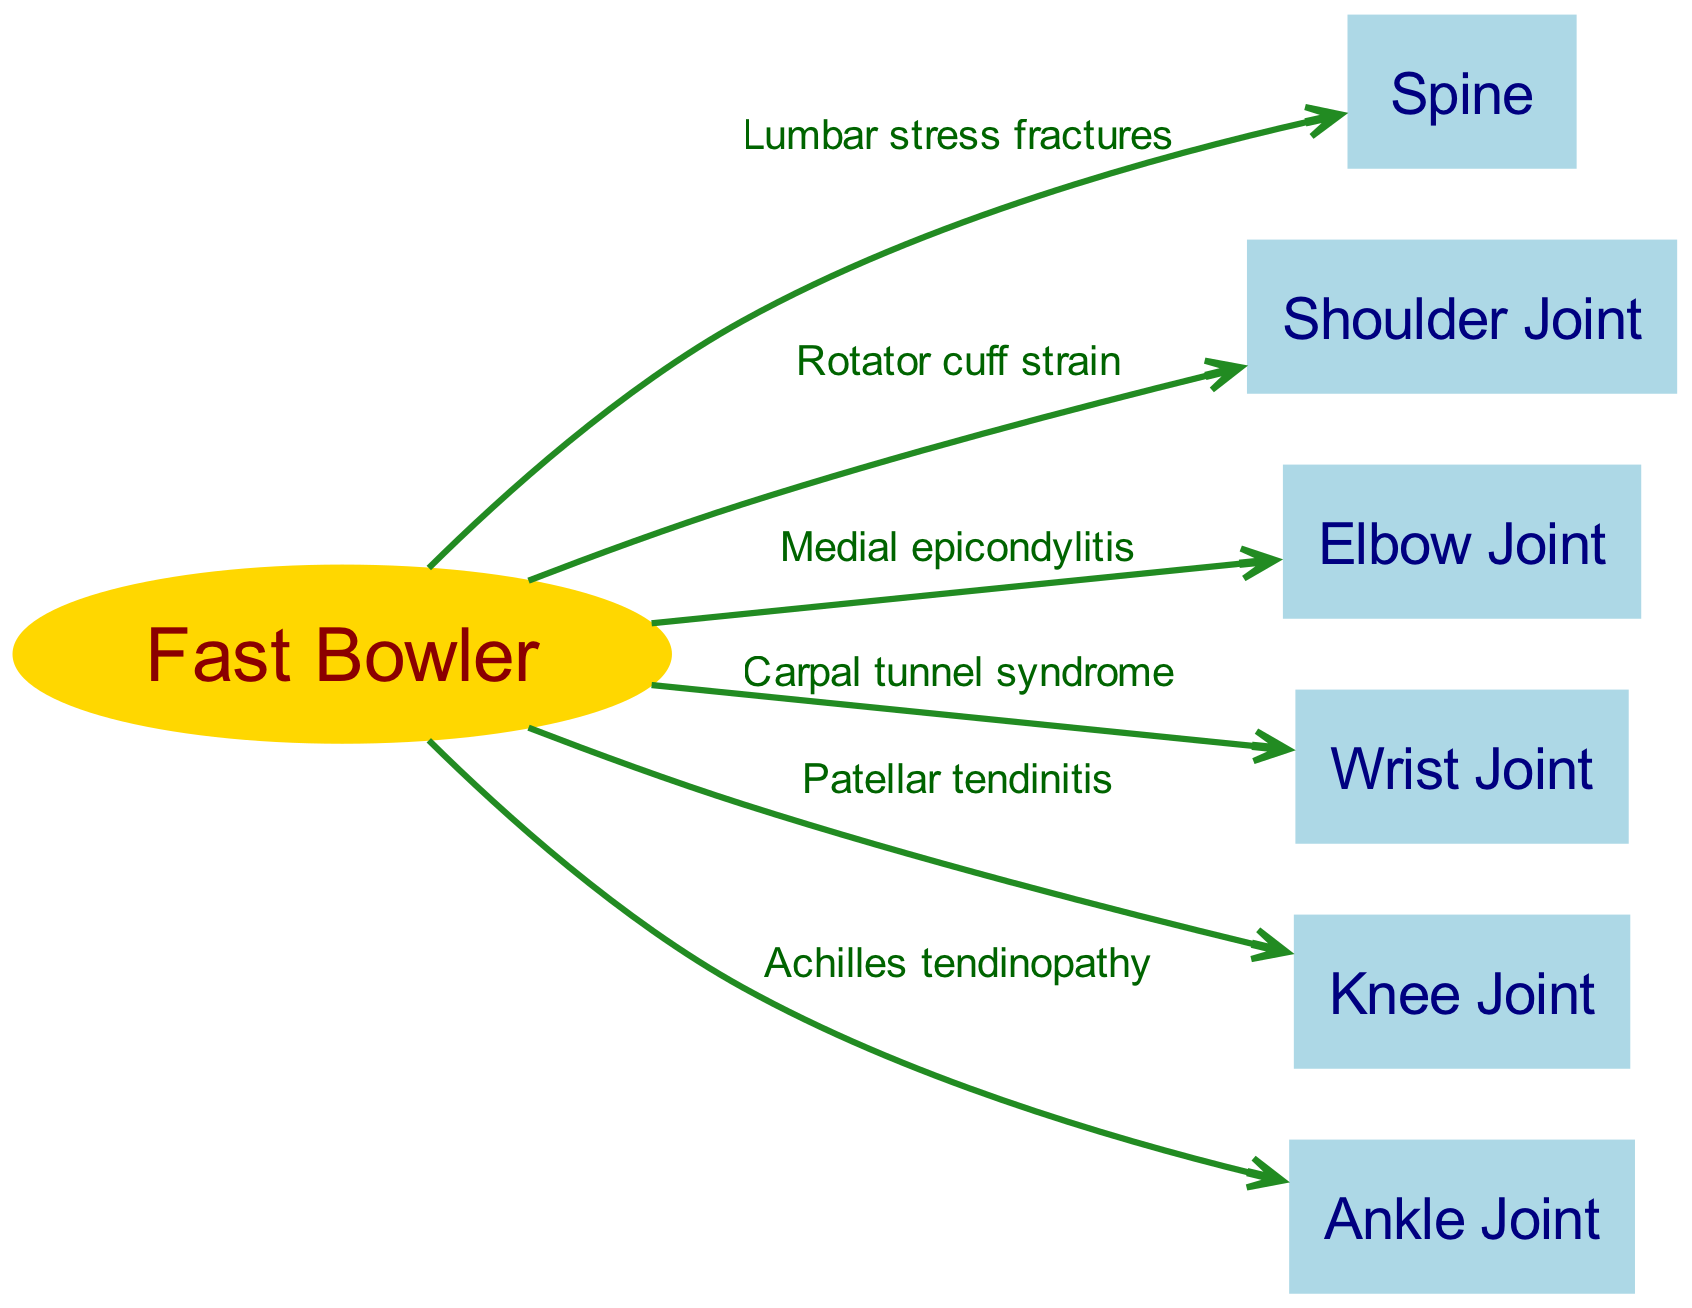What are the stress-related injuries indicated on the spine? The diagram shows "Lumbar stress fractures" as the injury related to the spine. It is directly connected from the fast bowler node to the spine node.
Answer: Lumbar stress fractures How many joints are listed in the biomechanical analysis? The diagram lists six joints: shoulder, elbow, wrist, knee, and ankle, which are all identified as stress points in the analysis. Counting these gives a total of six joints.
Answer: 6 What type of injury is connected to the elbow joint? The edge from the bowler node to the elbow node is labeled "Medial epicondylitis," indicating the specific injury associated with the elbow joint.
Answer: Medial epicondylitis Which joint is affected by Achilles tendinopathy? The arrow labeled "Achilles tendinopathy" goes from the fast bowler to the ankle joint, indicating that the injury affects the ankle.
Answer: Ankle Joint Is there a connection between the fast bowler and the shoulder joint? Yes, there is an edge from the fast bowler node to the shoulder joint node, labeled "Rotator cuff strain," indicating a specific injury related to this joint.
Answer: Yes What is the relationship between the fast bowler and knee joint? The diagram details that the fast bowler experiences "Patellar tendinitis," which is the injury connected to the knee joint from the bowler node.
Answer: Patellar tendinitis Which stress injury is linked to the wrist joint? The diagram shows that "Carpal tunnel syndrome" is connected to the wrist joint, highlighting it as the injury relevant for that joint.
Answer: Carpal tunnel syndrome Name one of the stress points highlighted in the diagram. The diagram highlights several stress points. One example is the "Shoulder Joint," which has "Rotator cuff strain" as the indicated injury.
Answer: Shoulder Joint What does the arrow represent from the bowler to the spine? The arrow labeled "Lumbar stress fractures" represents a specific type of injury that highlights the stress experienced on the spine due to the bowler's action.
Answer: Lumbar stress fractures 